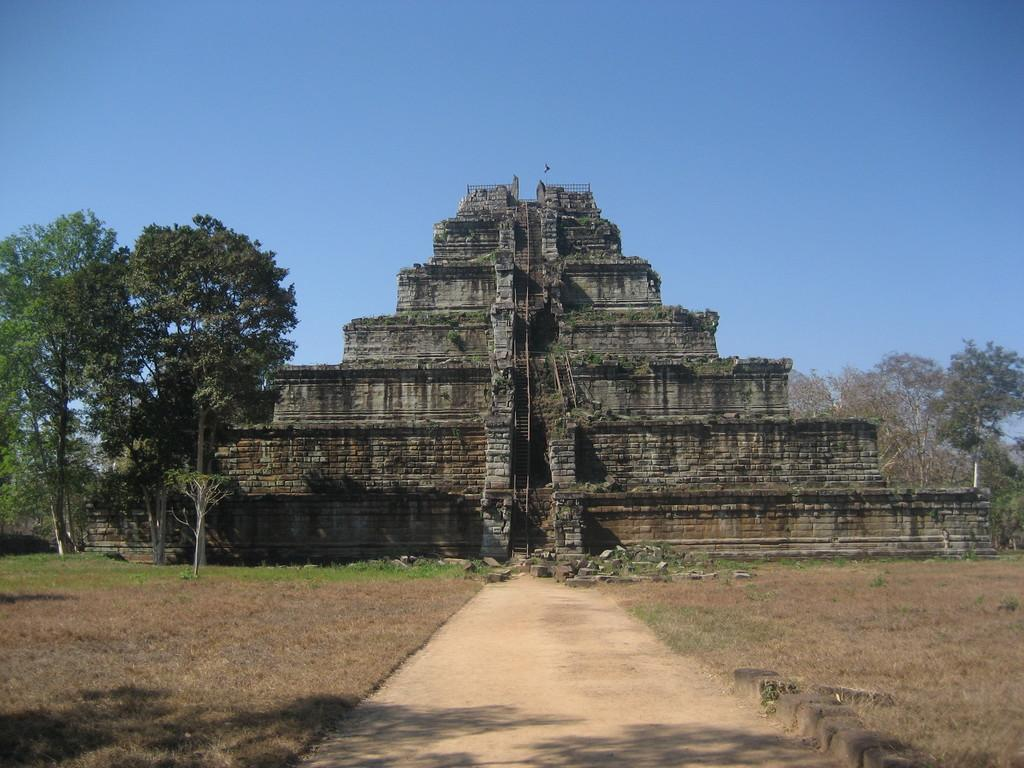What is the main subject of the image? There is a Koh Ker in the image. What can be seen beside the Koh Ker? There are trees beside the Koh Ker. What can be seen behind the Koh Ker? There are trees behind the Koh Ker. How many owls are sitting on the Koh Ker in the image? There are no owls present in the image; it only features the Koh Ker and trees. 